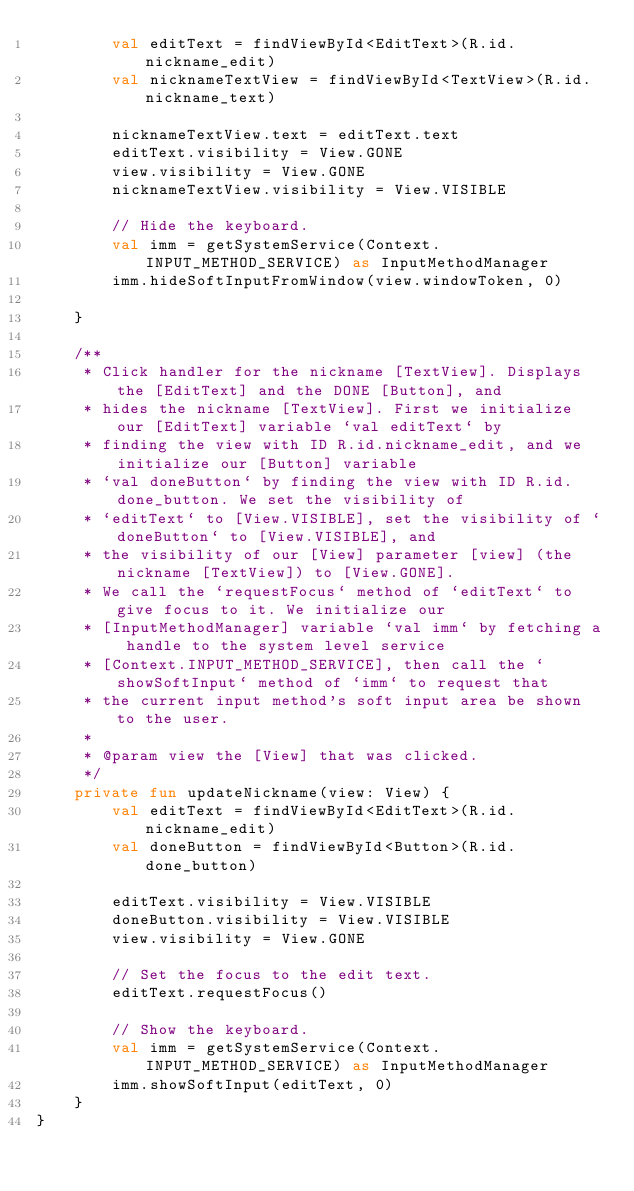<code> <loc_0><loc_0><loc_500><loc_500><_Kotlin_>        val editText = findViewById<EditText>(R.id.nickname_edit)
        val nicknameTextView = findViewById<TextView>(R.id.nickname_text)

        nicknameTextView.text = editText.text
        editText.visibility = View.GONE
        view.visibility = View.GONE
        nicknameTextView.visibility = View.VISIBLE

        // Hide the keyboard.
        val imm = getSystemService(Context.INPUT_METHOD_SERVICE) as InputMethodManager
        imm.hideSoftInputFromWindow(view.windowToken, 0)

    }

    /**
     * Click handler for the nickname [TextView]. Displays the [EditText] and the DONE [Button], and
     * hides the nickname [TextView]. First we initialize our [EditText] variable `val editText` by
     * finding the view with ID R.id.nickname_edit, and we initialize our [Button] variable
     * `val doneButton` by finding the view with ID R.id.done_button. We set the visibility of
     * `editText` to [View.VISIBLE], set the visibility of `doneButton` to [View.VISIBLE], and
     * the visibility of our [View] parameter [view] (the nickname [TextView]) to [View.GONE].
     * We call the `requestFocus` method of `editText` to give focus to it. We initialize our
     * [InputMethodManager] variable `val imm` by fetching a handle to the system level service
     * [Context.INPUT_METHOD_SERVICE], then call the `showSoftInput` method of `imm` to request that
     * the current input method's soft input area be shown to the user.
     *
     * @param view the [View] that was clicked.
     */
    private fun updateNickname(view: View) {
        val editText = findViewById<EditText>(R.id.nickname_edit)
        val doneButton = findViewById<Button>(R.id.done_button)

        editText.visibility = View.VISIBLE
        doneButton.visibility = View.VISIBLE
        view.visibility = View.GONE

        // Set the focus to the edit text.
        editText.requestFocus()

        // Show the keyboard.
        val imm = getSystemService(Context.INPUT_METHOD_SERVICE) as InputMethodManager
        imm.showSoftInput(editText, 0)
    }
}</code> 